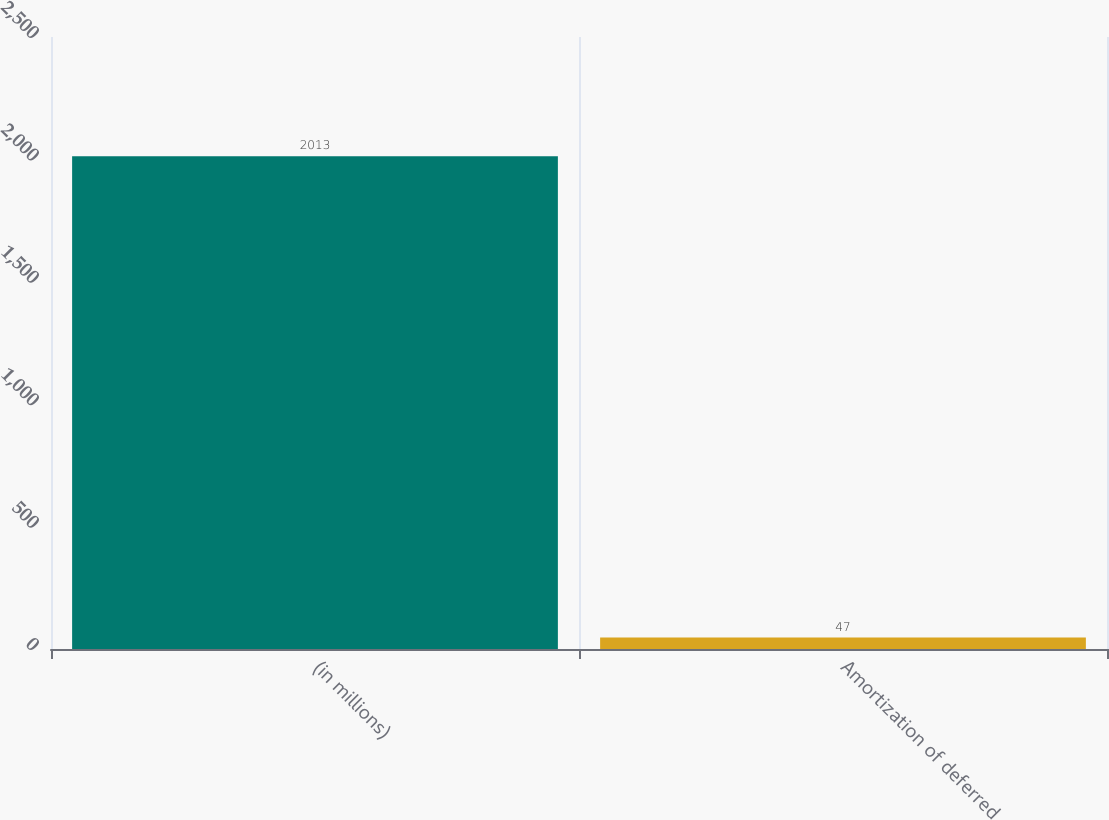Convert chart. <chart><loc_0><loc_0><loc_500><loc_500><bar_chart><fcel>(in millions)<fcel>Amortization of deferred<nl><fcel>2013<fcel>47<nl></chart> 